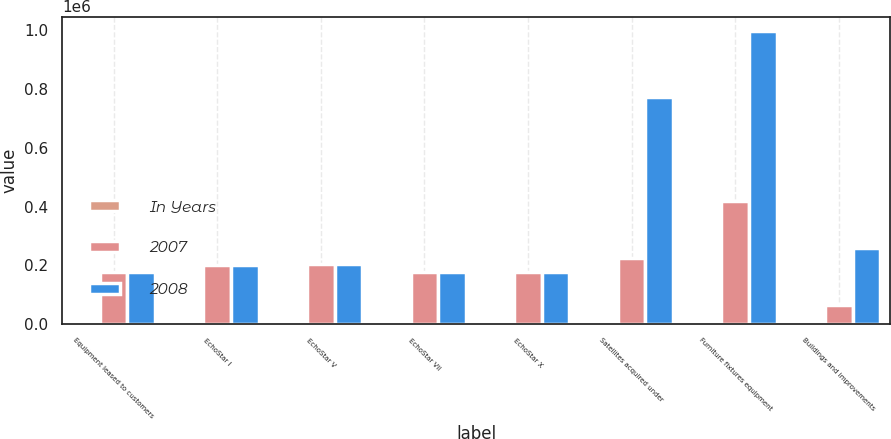Convert chart. <chart><loc_0><loc_0><loc_500><loc_500><stacked_bar_chart><ecel><fcel>Equipment leased to customers<fcel>EchoStar I<fcel>EchoStar V<fcel>EchoStar VII<fcel>EchoStar X<fcel>Satellites acquired under<fcel>Furniture fixtures equipment<fcel>Buildings and improvements<nl><fcel>In Years<fcel>25<fcel>12<fcel>9<fcel>12<fcel>12<fcel>1015<fcel>110<fcel>140<nl><fcel>2007<fcel>177096<fcel>201607<fcel>203511<fcel>177000<fcel>177192<fcel>223423<fcel>419758<fcel>64872<nl><fcel>2008<fcel>177096<fcel>201607<fcel>203511<fcel>177000<fcel>177192<fcel>775050<fcel>997521<fcel>260153<nl></chart> 